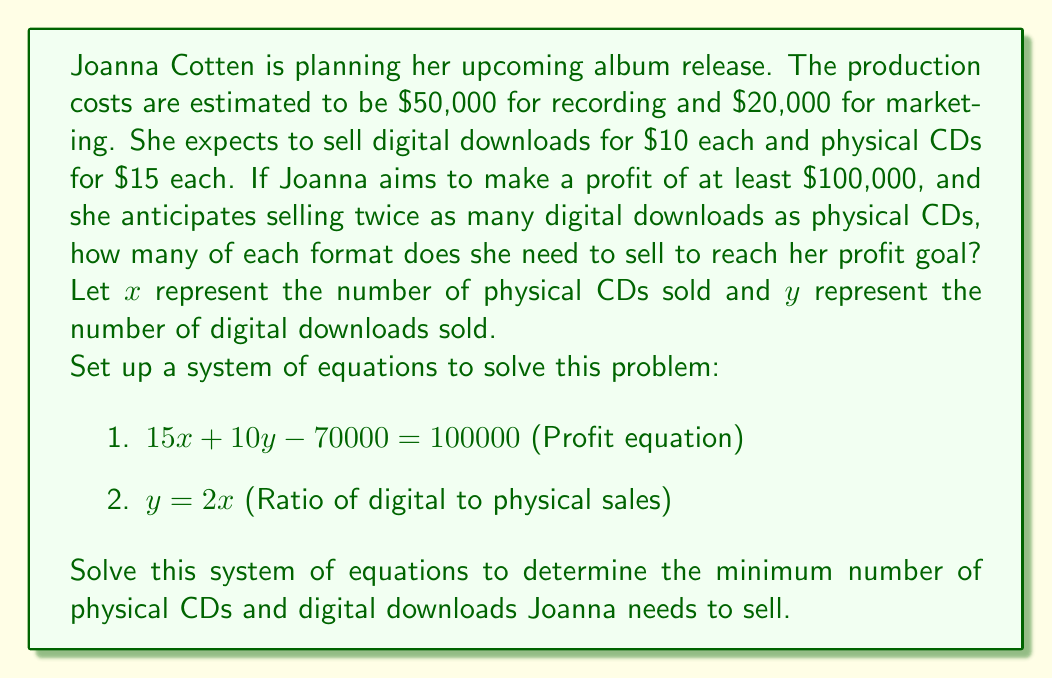What is the answer to this math problem? Let's solve this system of equations step by step:

1) We start with our two equations:
   $15x + 10y - 70000 = 100000$ (Profit equation)
   $y = 2x$ (Ratio equation)

2) Substitute the ratio equation into the profit equation:
   $15x + 10(2x) - 70000 = 100000$

3) Simplify:
   $15x + 20x - 70000 = 100000$
   $35x - 70000 = 100000$

4) Add 70000 to both sides:
   $35x = 170000$

5) Divide both sides by 35:
   $x = \frac{170000}{35} = 4857.14$

6) Since we can't sell a fraction of a CD, we round up to the nearest whole number:
   $x = 4858$ physical CDs

7) Now we can calculate $y$ using the ratio equation:
   $y = 2x = 2(4858) = 9716$ digital downloads

8) Let's verify our profit:
   Profit = Revenue - Costs
   $$ \begin{align*}
   \text{Profit} &= (15 \cdot 4858 + 10 \cdot 9716) - (50000 + 20000) \\
   &= (72870 + 97160) - 70000 \\
   &= 170030 - 70000 \\
   &= 100030
   \end{align*} $$

   This exceeds the $100,000 profit goal, confirming our solution.
Answer: Joanna Cotten needs to sell at least 4,858 physical CDs and 9,716 digital downloads to reach her profit goal of $100,000. 